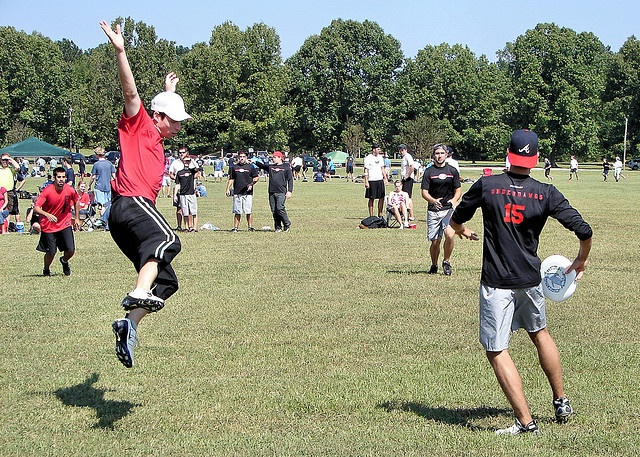Describe the objects in this image and their specific colors. I can see people in lightblue, black, gray, lightgray, and darkgray tones, people in lightblue, black, white, salmon, and gray tones, people in lightblue, black, white, darkgray, and gray tones, people in lightblue, black, gray, white, and maroon tones, and people in lightblue, black, salmon, maroon, and brown tones in this image. 